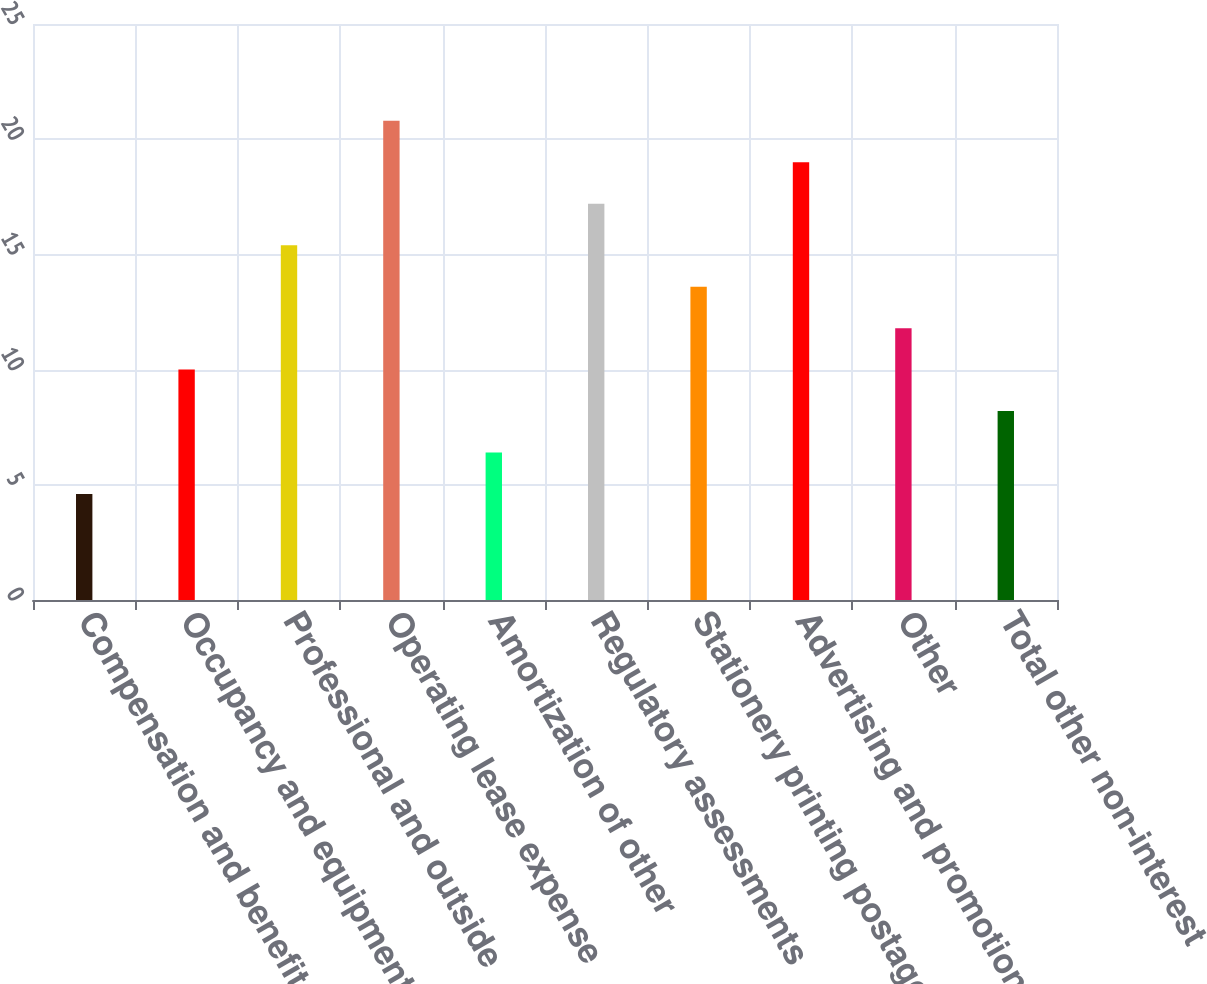Convert chart to OTSL. <chart><loc_0><loc_0><loc_500><loc_500><bar_chart><fcel>Compensation and benefits<fcel>Occupancy and equipment<fcel>Professional and outside<fcel>Operating lease expense<fcel>Amortization of other<fcel>Regulatory assessments<fcel>Stationery printing postage<fcel>Advertising and promotion<fcel>Other<fcel>Total other non-interest<nl><fcel>4.6<fcel>10<fcel>15.4<fcel>20.8<fcel>6.4<fcel>17.2<fcel>13.6<fcel>19<fcel>11.8<fcel>8.2<nl></chart> 